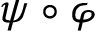<formula> <loc_0><loc_0><loc_500><loc_500>\psi \circ \varphi</formula> 